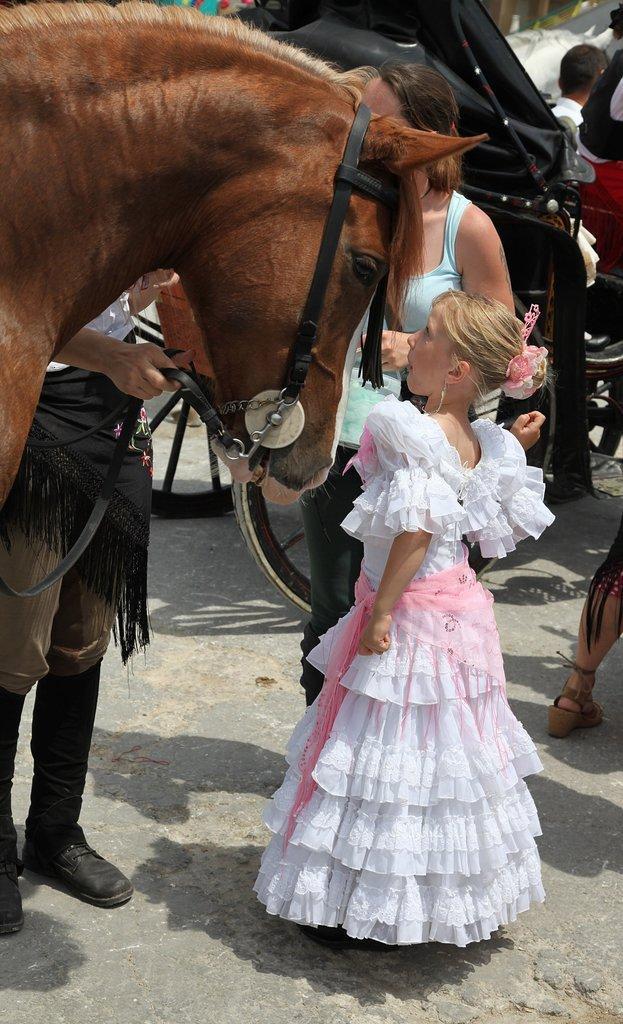Can you describe this image briefly? In this image in the foreground there is one horse and two people, and one girl standing. At the bottom there is walkway and in the background there are some vehicles, and some people and some objects. 